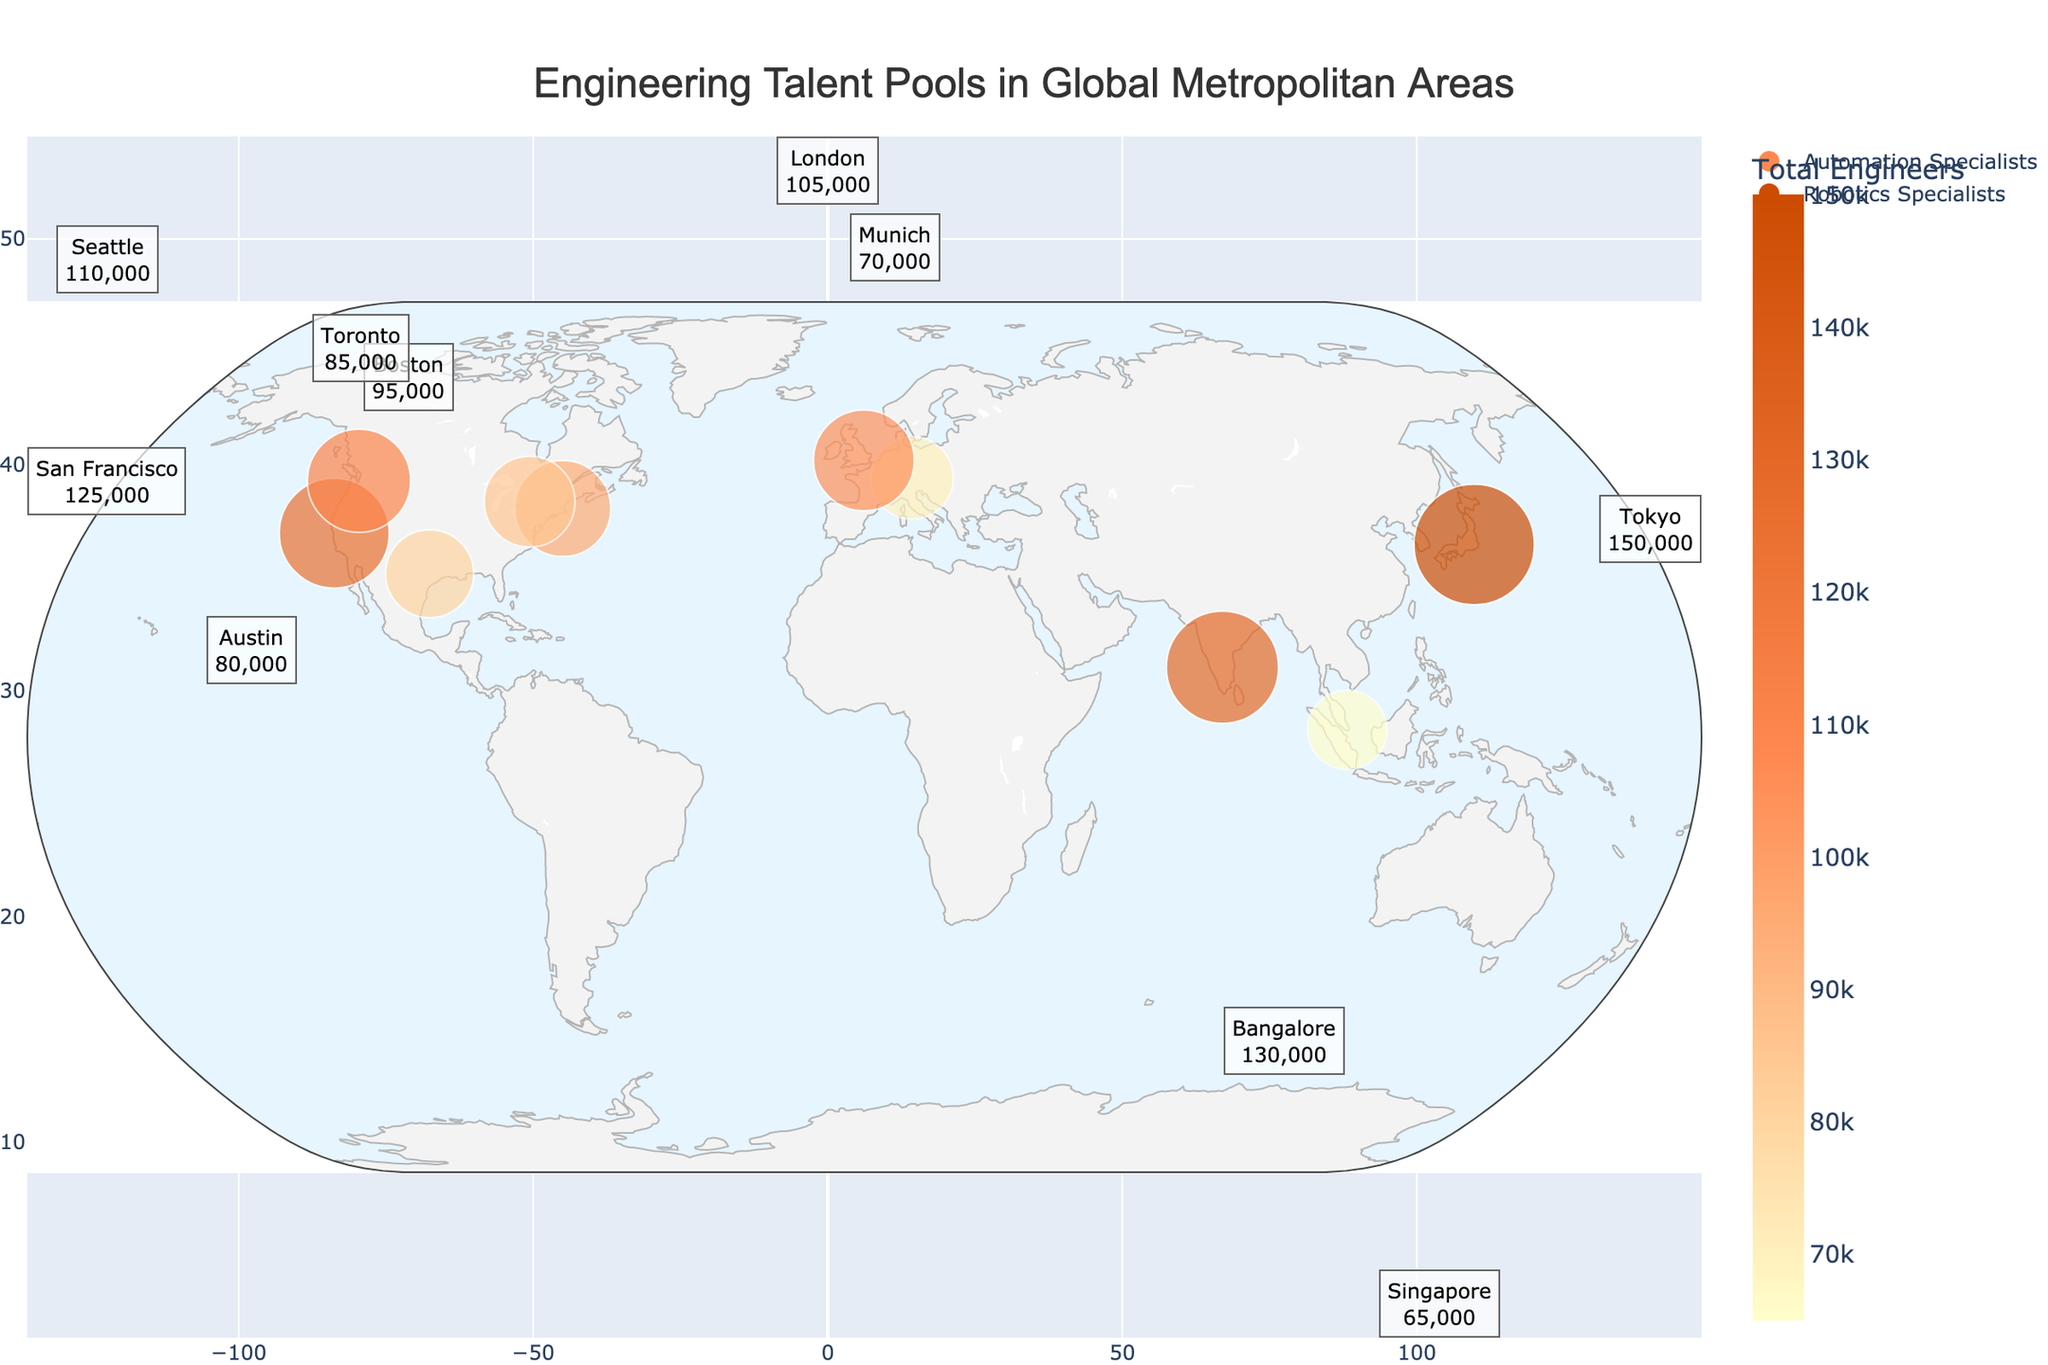What is the title of the figure? The title is usually located at the top center of the figure. By reading it, we can understand the general theme or topic that the plot covers.
Answer: Engineering Talent Pools in Global Metropolitan Areas Which city has the highest total number of engineers? By looking at the size of the bubbles on the map and the annotations next to each city, we can identify the city with the largest size bubble and highest number.
Answer: Tokyo What specialization is represented by the dark orange color in the custom legend? The custom legend at the bottom right of the plot shows two specializations with different colors. Identifying the color allows us to associate it with the corresponding specialization.
Answer: Robotics Specialists Which cities have more than 100,000 total engineers? Checking the annotations next to each city for those with numbers greater than 100,000. These annotations provide specific counts.
Answer: San Francisco, Tokyo, Bangalore, London, Seattle How many cities have fewer than 80,000 total engineers? Counting the number of cities with annotations showing totals less than 80,000 helps determine this.
Answer: 3 What is the sum of total engineers in San Francisco, Boston, and Seattle? By adding the total number of engineers for these specified cities: 125,000 (San Francisco), 95,000 (Boston), and 110,000 (Seattle). Sum these numbers.
Answer: 330,000 Which city has more automation specialists: Austin or Munich? Compare the automation specialist counts from the city annotations for Austin and Munich. Austin has 12,000, and Munich has 10,500.
Answer: Austin What is the average number of robotics specialists in the listed cities? To find the average, sum the number of robotics specialists in all cities and divide by the number of cities (10): (12,500+9,500+11,000+8,000+7,000+15,000+6,500+8,500+10,500+13,000) / 10 = 101,500 / 10.
Answer: 10,150 Which two cities are closest to each other geographically based on latitude and longitude? Examine the geographic coordinates (latitude and longitude) of each city, and find the pair with the smallest differences in these values.
Answer: San Francisco and Seattle 